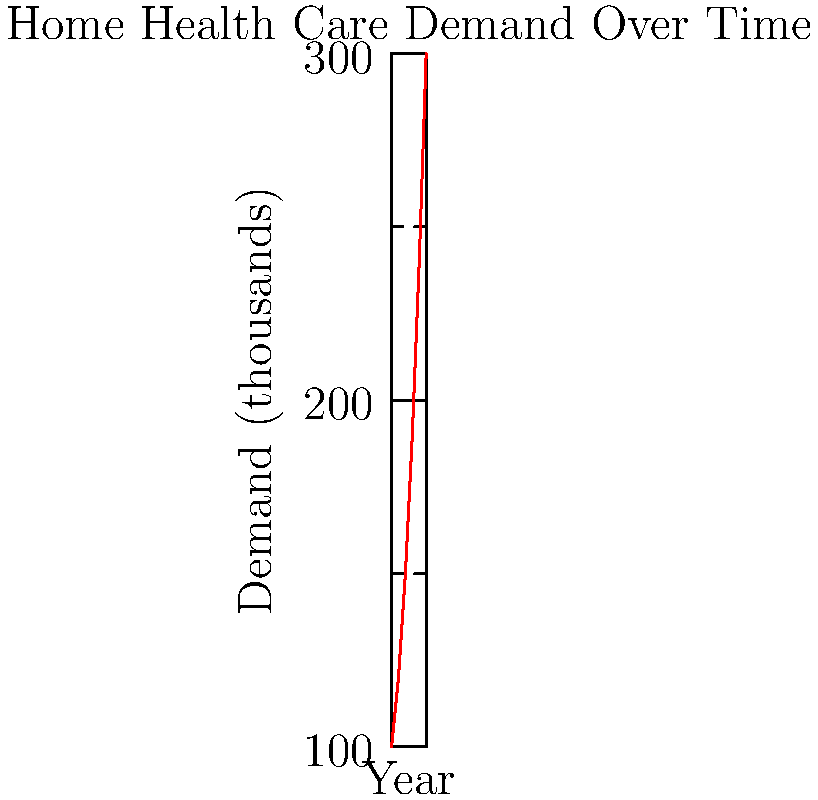The graph shows the increasing demand for home health care services from 2010 to 2020. What was the approximate percentage increase in demand between 2010 and 2020? To calculate the percentage increase in demand between 2010 and 2020:

1. Identify the demand values:
   - 2010: 100 thousand
   - 2020: 300 thousand

2. Calculate the difference:
   $300 - 100 = 200$ thousand

3. Divide the difference by the initial value:
   $\frac{200}{100} = 2$

4. Convert to a percentage:
   $2 \times 100\% = 200\%$

The demand for home health care services increased by approximately 200% between 2010 and 2020.
Answer: 200% 